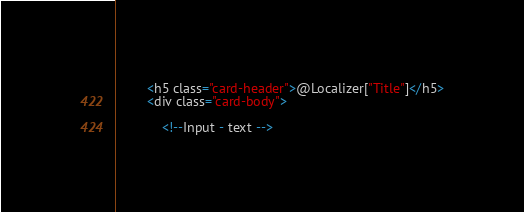<code> <loc_0><loc_0><loc_500><loc_500><_C#_>		<h5 class="card-header">@Localizer["Title"]</h5>
		<div class="card-body">

			<!--Input - text --></code> 